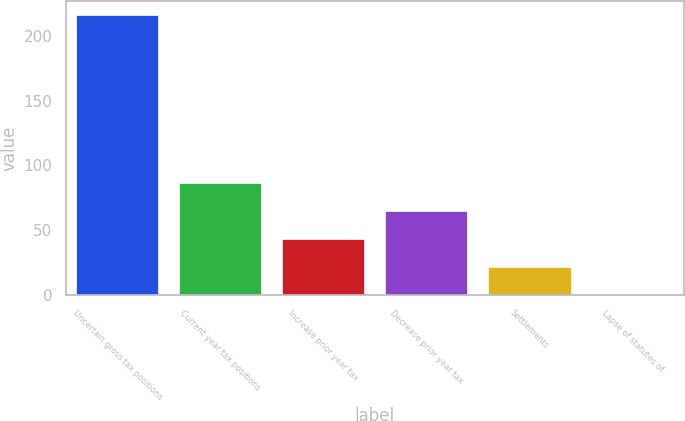Convert chart to OTSL. <chart><loc_0><loc_0><loc_500><loc_500><bar_chart><fcel>Uncertain gross tax positions<fcel>Current year tax positions<fcel>Increase prior year tax<fcel>Decrease prior year tax<fcel>Settlements<fcel>Lapse of statutes of<nl><fcel>216.1<fcel>86.56<fcel>43.38<fcel>64.97<fcel>21.79<fcel>0.2<nl></chart> 